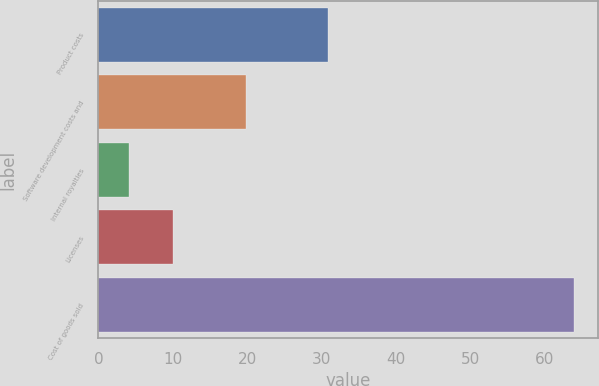Convert chart to OTSL. <chart><loc_0><loc_0><loc_500><loc_500><bar_chart><fcel>Product costs<fcel>Software development costs and<fcel>Internal royalties<fcel>Licenses<fcel>Cost of goods sold<nl><fcel>30.9<fcel>19.9<fcel>4.1<fcel>10.09<fcel>64<nl></chart> 